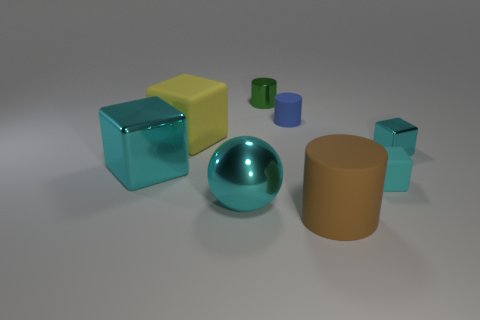Subtract all yellow cylinders. How many cyan cubes are left? 3 Subtract all gray blocks. Subtract all red spheres. How many blocks are left? 4 Add 1 large green cylinders. How many objects exist? 9 Subtract all cylinders. How many objects are left? 5 Add 4 big brown metallic blocks. How many big brown metallic blocks exist? 4 Subtract 0 blue balls. How many objects are left? 8 Subtract all small gray shiny blocks. Subtract all small metallic cylinders. How many objects are left? 7 Add 3 cyan matte things. How many cyan matte things are left? 4 